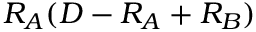Convert formula to latex. <formula><loc_0><loc_0><loc_500><loc_500>R _ { A } ( D - R _ { A } + R _ { B } )</formula> 